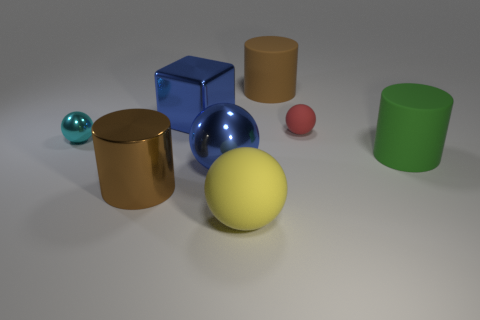Add 1 large cylinders. How many objects exist? 9 Subtract all cubes. How many objects are left? 7 Add 1 blue rubber spheres. How many blue rubber spheres exist? 1 Subtract 0 brown blocks. How many objects are left? 8 Subtract all tiny rubber balls. Subtract all small blue cylinders. How many objects are left? 7 Add 6 brown shiny things. How many brown shiny things are left? 7 